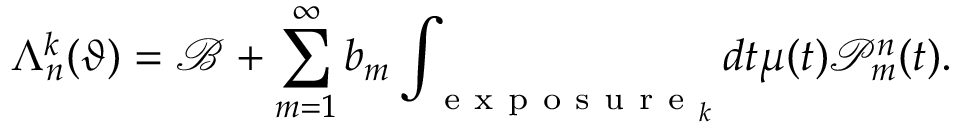Convert formula to latex. <formula><loc_0><loc_0><loc_500><loc_500>\Lambda _ { n } ^ { k } ( \vartheta ) = \mathcal { B } + \sum _ { m = 1 } ^ { \infty } b _ { m } \int _ { e x p o s u r e _ { k } } d t \mu ( t ) \mathcal { P } _ { m } ^ { n } ( t ) .</formula> 